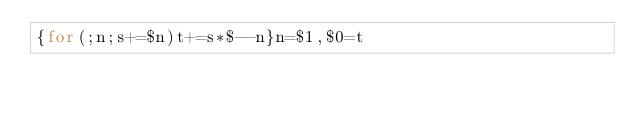Convert code to text. <code><loc_0><loc_0><loc_500><loc_500><_Awk_>{for(;n;s+=$n)t+=s*$--n}n=$1,$0=t</code> 